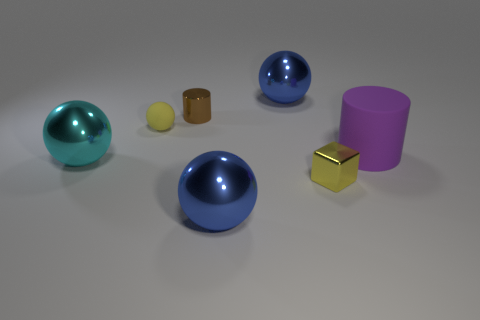Are there any matte balls of the same size as the rubber cylinder?
Your response must be concise. No. Are there more big things that are behind the big purple matte object than small yellow rubber balls that are to the right of the small yellow metallic object?
Keep it short and to the point. Yes. Are the large blue thing in front of the rubber cylinder and the large thing to the right of the yellow cube made of the same material?
Your answer should be very brief. No. There is a brown metal object that is the same size as the matte ball; what is its shape?
Offer a very short reply. Cylinder. Is there a tiny thing that has the same shape as the big purple thing?
Ensure brevity in your answer.  Yes. There is a large object that is in front of the cube; does it have the same color as the ball that is behind the brown shiny thing?
Your response must be concise. Yes. Are there any cylinders on the left side of the cyan metal sphere?
Your answer should be compact. No. What is the material of the ball that is left of the small cylinder and in front of the purple matte thing?
Offer a terse response. Metal. Is the yellow thing that is behind the cyan object made of the same material as the purple cylinder?
Ensure brevity in your answer.  Yes. What material is the small yellow sphere?
Ensure brevity in your answer.  Rubber. 